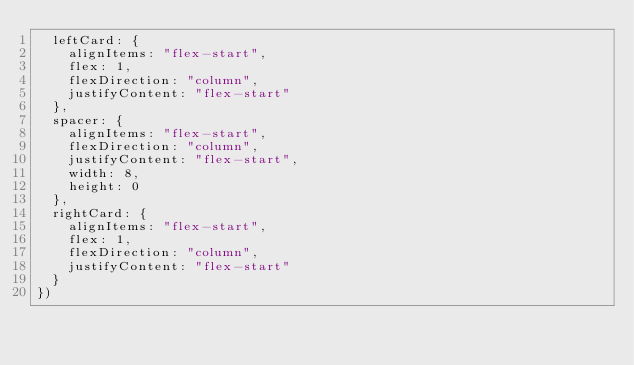<code> <loc_0><loc_0><loc_500><loc_500><_JavaScript_>  leftCard: {
    alignItems: "flex-start",
    flex: 1,
    flexDirection: "column",
    justifyContent: "flex-start"
  },
  spacer: {
    alignItems: "flex-start",
    flexDirection: "column",
    justifyContent: "flex-start",
    width: 8,
    height: 0
  },
  rightCard: {
    alignItems: "flex-start",
    flex: 1,
    flexDirection: "column",
    justifyContent: "flex-start"
  }
})</code> 